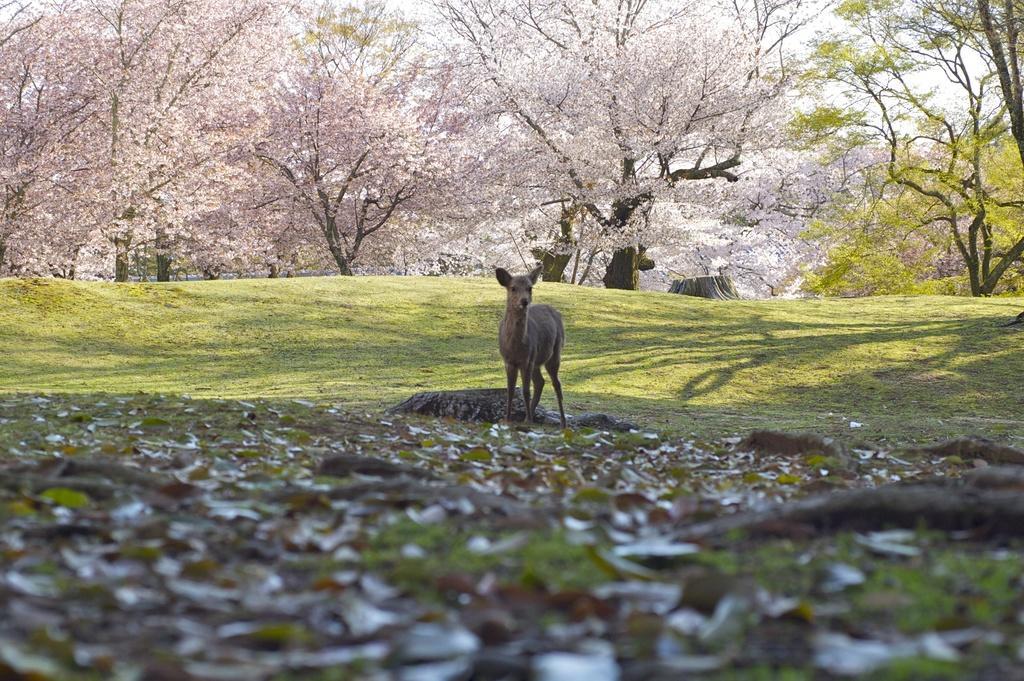In one or two sentences, can you explain what this image depicts? This image consists of a deer. At the bottom, there are dried leaves on the ground. In the middle, there is green grass. In the background, there are trees with pink color leaves. 